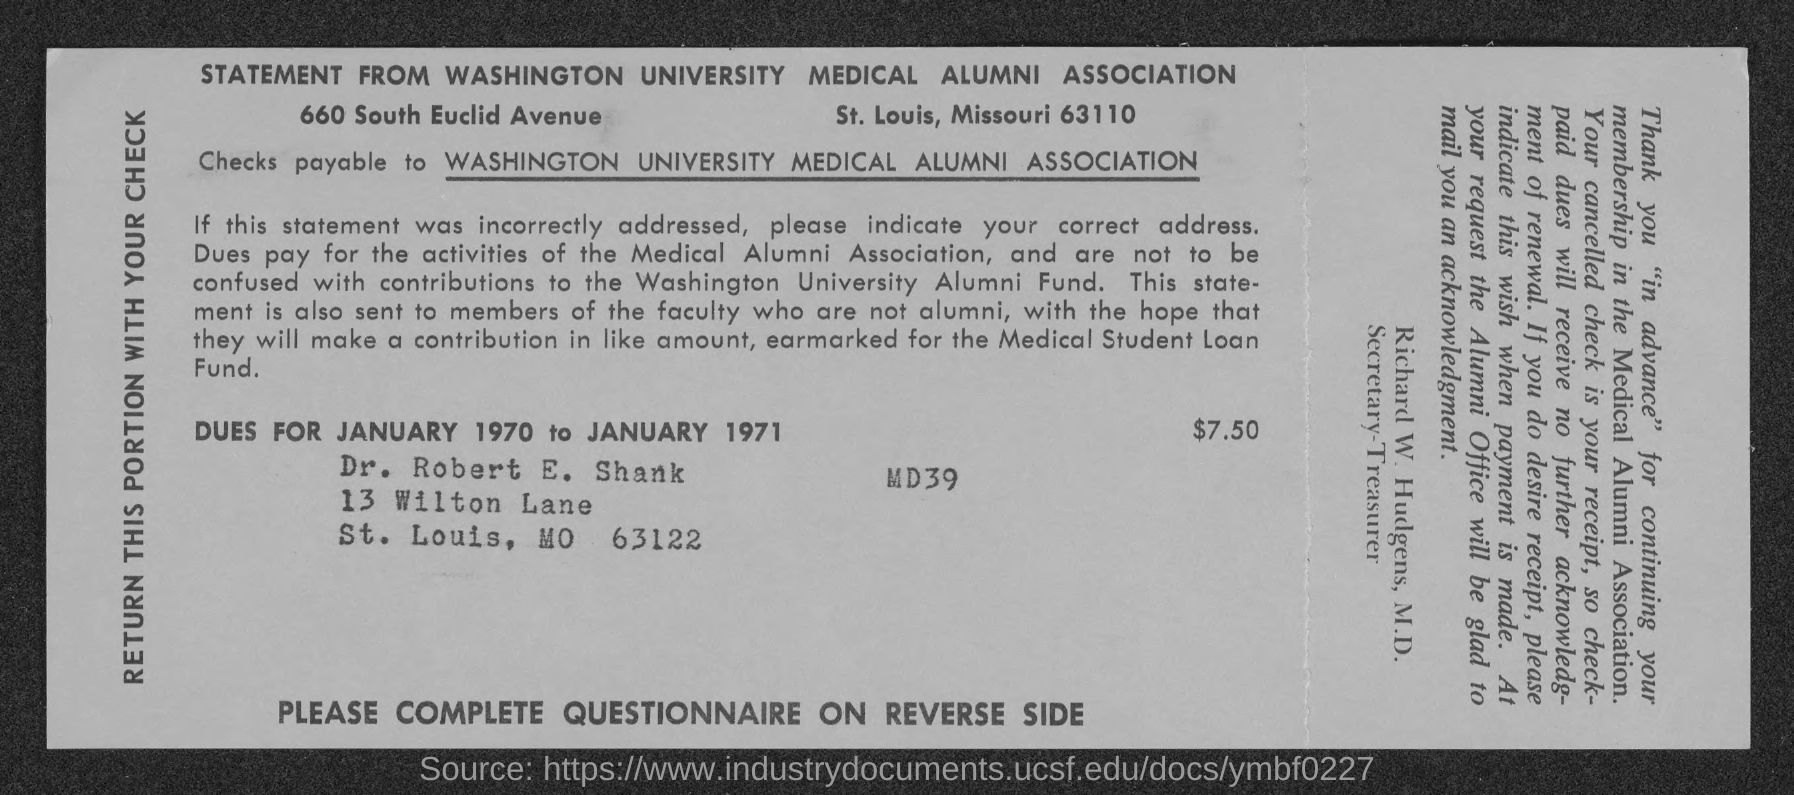What is due Amount?
Your response must be concise. $7.50. 